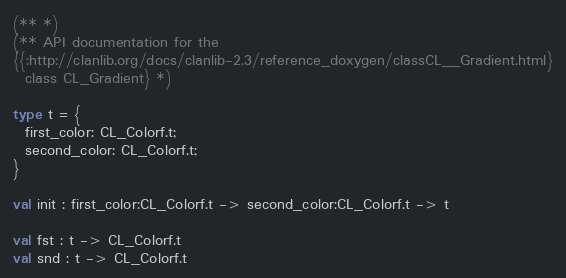Convert code to text. <code><loc_0><loc_0><loc_500><loc_500><_OCaml_>(** *)
(** API documentation for the
{{:http://clanlib.org/docs/clanlib-2.3/reference_doxygen/classCL__Gradient.html}
  class CL_Gradient} *)

type t = {
  first_color: CL_Colorf.t;
  second_color: CL_Colorf.t;
}

val init : first_color:CL_Colorf.t -> second_color:CL_Colorf.t -> t

val fst : t -> CL_Colorf.t
val snd : t -> CL_Colorf.t
</code> 